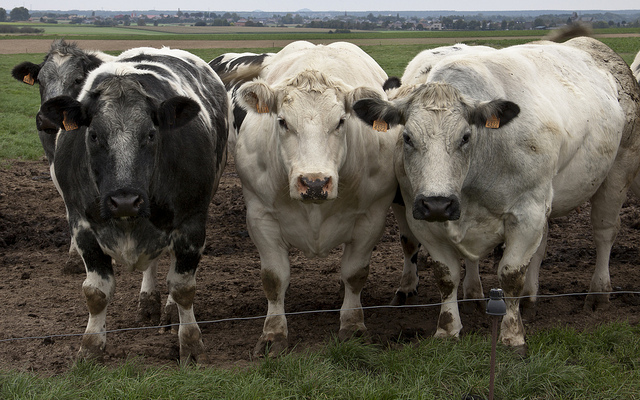Can you elaborate on the elements of the picture provided? The image captures a pastoral scene with five cows standing in a muddy field, indicating a rural or farming setting. On the left, a uniquely patterned black cow with white highlights demands attention due to its dark color contrasting against the lighter field. Beside it, a large white cow with a significant black patch on its face and body looks directly at the camera, adding a personal touch to the scene. As your eyes move right, there are three more cows; the two foremost are predominantly white, adding a sense of depth. The cow in the very back slightly raises its head above the others in the middle, adding a playful element to the composition. This detailed arrangement offers a glimpse into the life and environment of farm animals. 